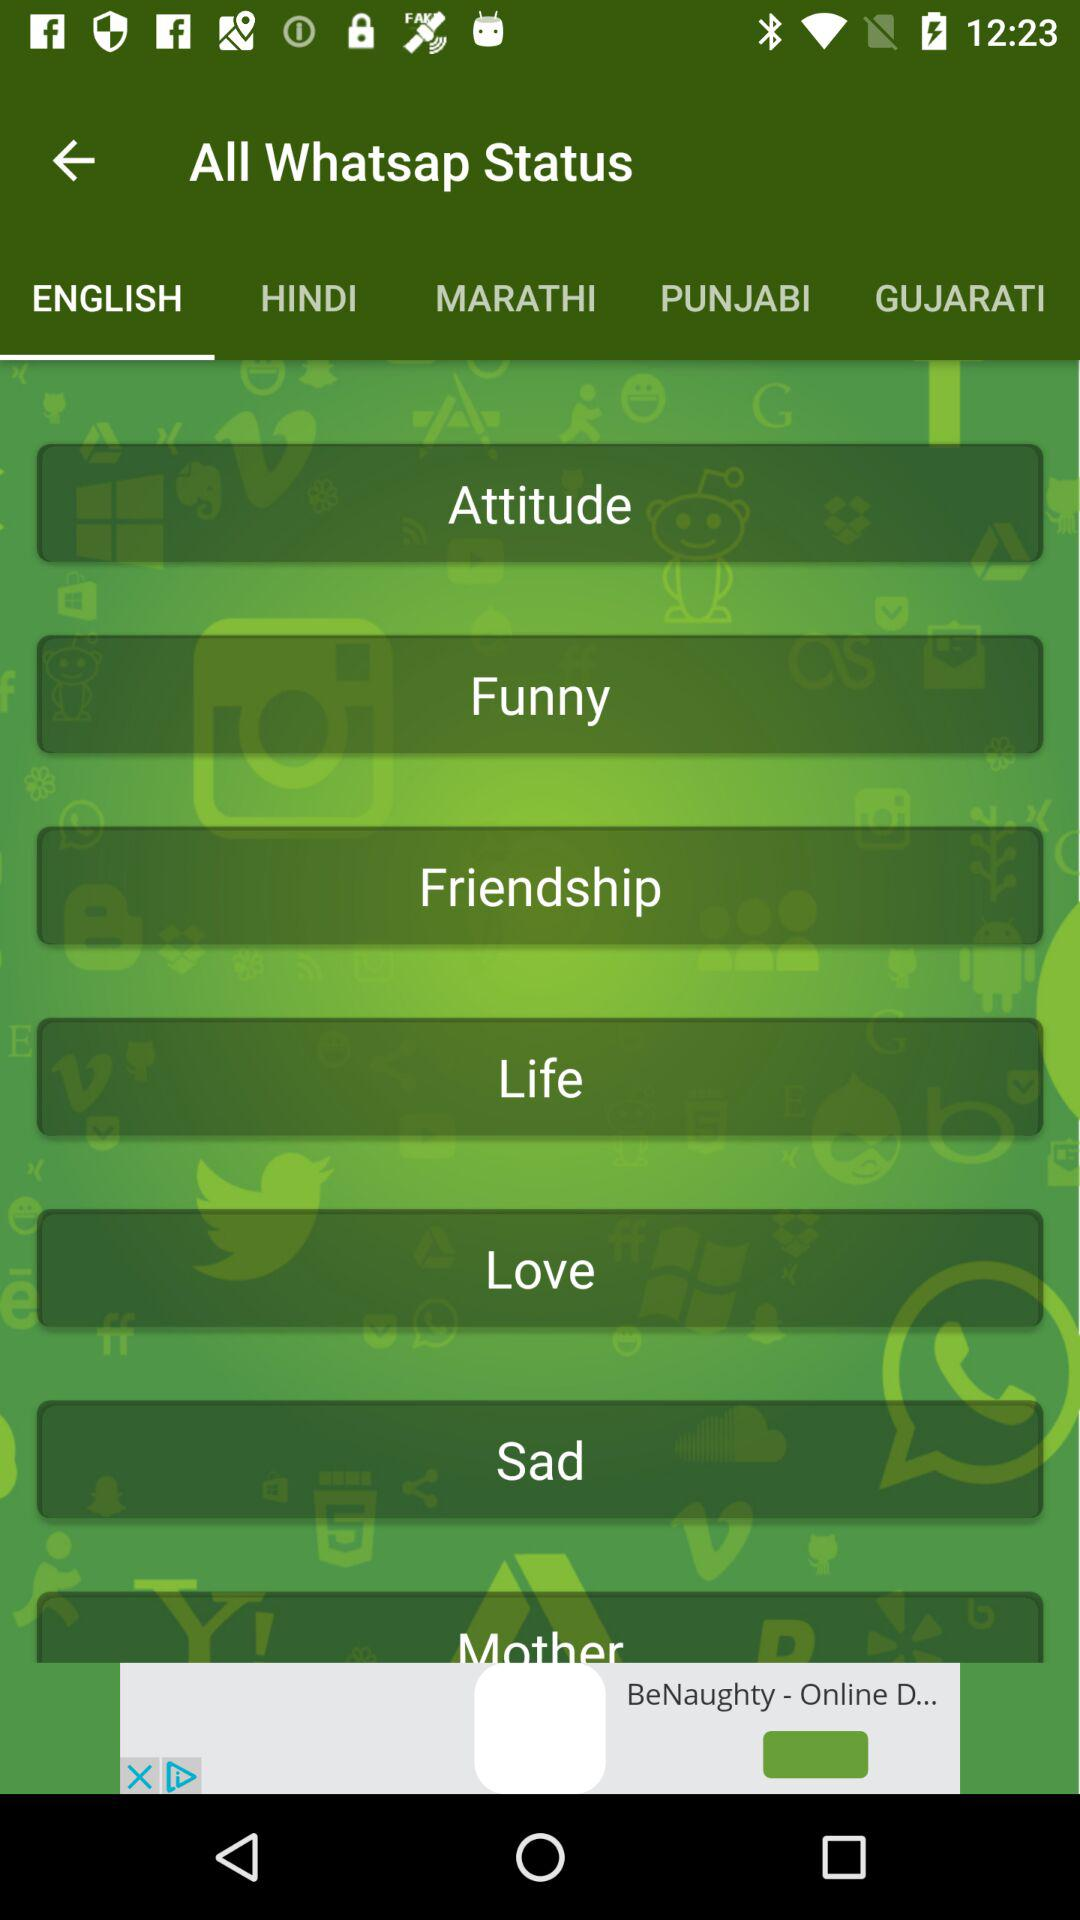Which tab is selected? The selected tab is "ENGLISH". 